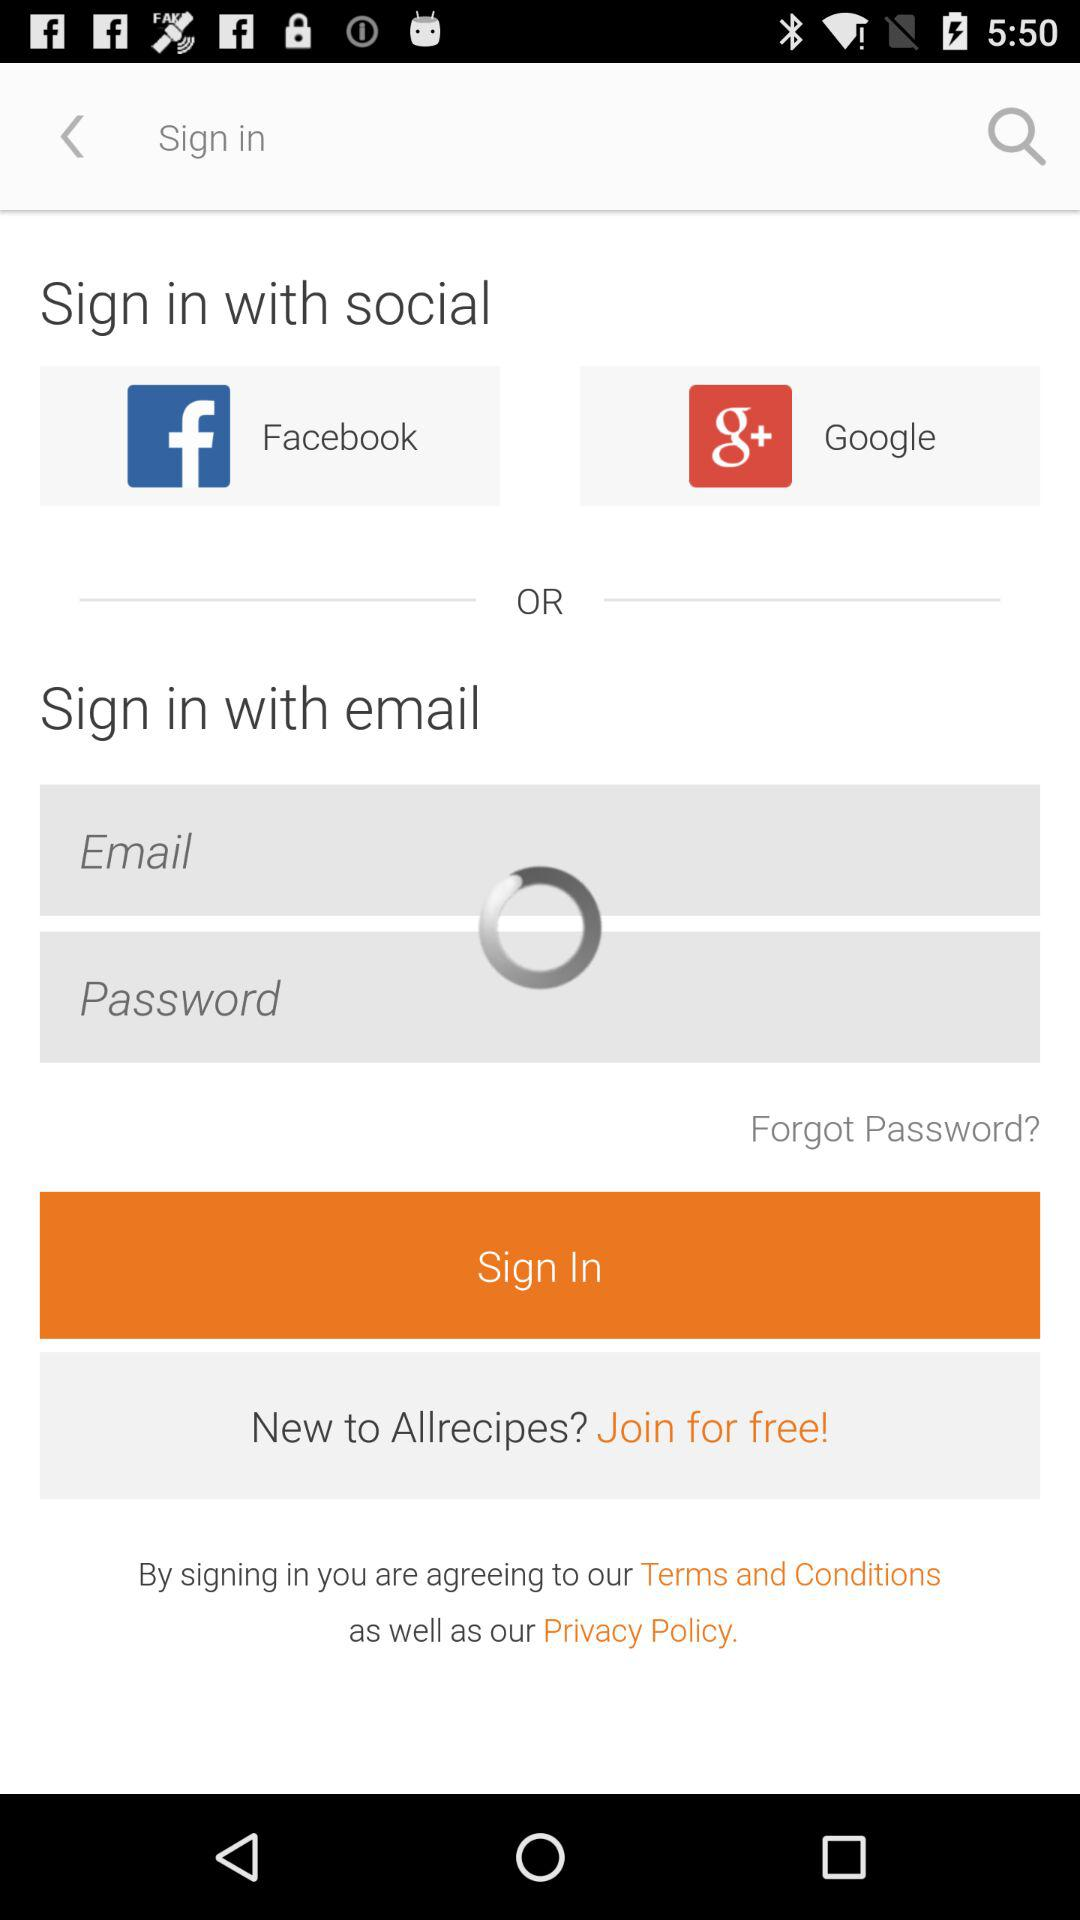How many text inputs are there for signing in?
Answer the question using a single word or phrase. 2 